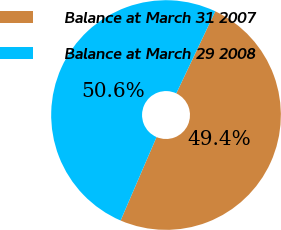Convert chart. <chart><loc_0><loc_0><loc_500><loc_500><pie_chart><fcel>Balance at March 31 2007<fcel>Balance at March 29 2008<nl><fcel>49.42%<fcel>50.58%<nl></chart> 